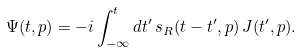Convert formula to latex. <formula><loc_0><loc_0><loc_500><loc_500>\Psi ( t , p ) = - i \int _ { - \infty } ^ { t } d t ^ { \prime } \, s _ { R } ( t - t ^ { \prime } , p ) \, J ( t ^ { \prime } , p ) .</formula> 